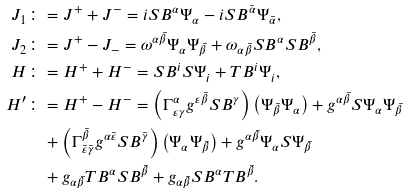Convert formula to latex. <formula><loc_0><loc_0><loc_500><loc_500>J _ { 1 } & \colon = J ^ { + } + J ^ { - } = i S B ^ { \alpha } \Psi _ { \alpha } - i S B ^ { \bar { \alpha } } \Psi _ { \bar { \alpha } } , \\ J _ { 2 } & \colon = J ^ { + } - J _ { - } = \omega ^ { \alpha \bar { \beta } } \Psi _ { \alpha } \Psi _ { \bar { \beta } } + \omega _ { \alpha \bar { \beta } } S B ^ { \alpha } S B ^ { \bar { \beta } } , \\ H & \colon = H ^ { + } + H ^ { - } = S B ^ { i } S \Psi _ { i } + T B ^ { i } \Psi _ { i } , \\ H ^ { \prime } & \colon = H ^ { + } - H ^ { - } = \left ( \Gamma ^ { \alpha } _ { \varepsilon \gamma } g ^ { \varepsilon \bar { \beta } } S B ^ { \gamma } \right ) \left ( \Psi _ { \bar { \beta } } \Psi _ { \alpha } \right ) + g ^ { \alpha \bar { \beta } } S \Psi _ { \alpha } \Psi _ { \bar { \beta } } \\ & \quad + \left ( \Gamma _ { \bar { \varepsilon } \bar { \gamma } } ^ { \bar { \beta } } g ^ { \alpha \bar { \varepsilon } } S B ^ { \bar { \gamma } } \right ) \left ( \Psi _ { \alpha } \Psi _ { \bar { \beta } } \right ) + g ^ { \alpha \bar { \beta } } \Psi _ { \alpha } S \Psi _ { \bar { \beta } } \\ & \quad + g _ { \alpha \bar { \beta } } T B ^ { \alpha } S B ^ { \bar { \beta } } + g _ { \alpha \bar { \beta } } S B ^ { \alpha } T B ^ { \bar { \beta } } .</formula> 